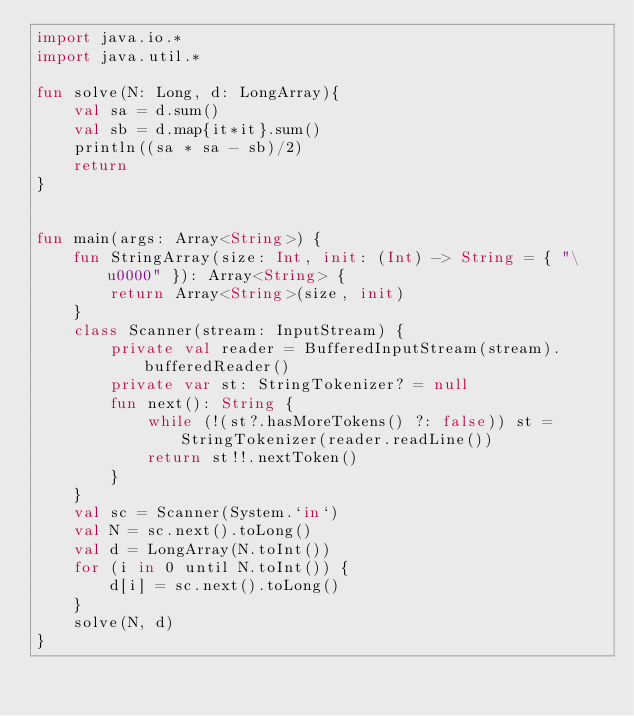<code> <loc_0><loc_0><loc_500><loc_500><_Kotlin_>import java.io.*
import java.util.*

fun solve(N: Long, d: LongArray){
    val sa = d.sum()
    val sb = d.map{it*it}.sum()
    println((sa * sa - sb)/2)
    return
}


fun main(args: Array<String>) {
    fun StringArray(size: Int, init: (Int) -> String = { "\u0000" }): Array<String> {
        return Array<String>(size, init)
    }
    class Scanner(stream: InputStream) {
        private val reader = BufferedInputStream(stream).bufferedReader()
        private var st: StringTokenizer? = null
        fun next(): String {
            while (!(st?.hasMoreTokens() ?: false)) st = StringTokenizer(reader.readLine())
            return st!!.nextToken()
        }
    }
    val sc = Scanner(System.`in`)
    val N = sc.next().toLong()
    val d = LongArray(N.toInt())
    for (i in 0 until N.toInt()) {
        d[i] = sc.next().toLong()
    }
    solve(N, d)
}

</code> 